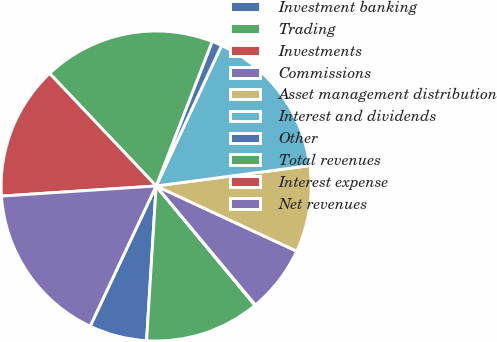Convert chart to OTSL. <chart><loc_0><loc_0><loc_500><loc_500><pie_chart><fcel>Investment banking<fcel>Trading<fcel>Investments<fcel>Commissions<fcel>Asset management distribution<fcel>Interest and dividends<fcel>Other<fcel>Total revenues<fcel>Interest expense<fcel>Net revenues<nl><fcel>6.02%<fcel>11.99%<fcel>0.06%<fcel>7.02%<fcel>9.01%<fcel>15.97%<fcel>1.05%<fcel>17.95%<fcel>13.98%<fcel>16.96%<nl></chart> 